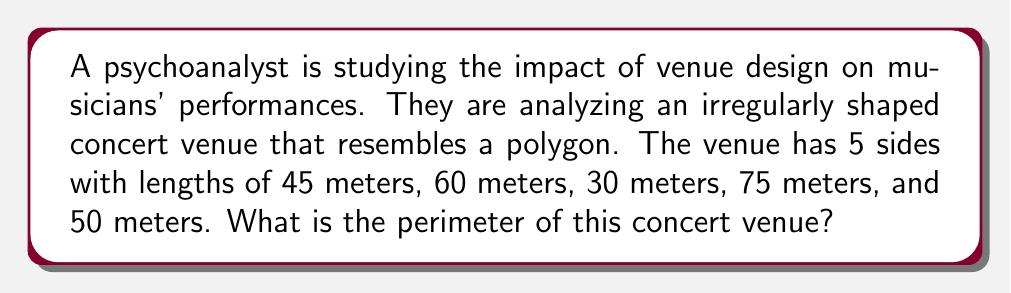Could you help me with this problem? To find the perimeter of the irregularly shaped concert venue, we need to sum up the lengths of all sides. Let's approach this step-by-step:

1. List the given side lengths:
   - Side 1: 45 meters
   - Side 2: 60 meters
   - Side 3: 30 meters
   - Side 4: 75 meters
   - Side 5: 50 meters

2. Set up the equation for the perimeter:
   $$P = s_1 + s_2 + s_3 + s_4 + s_5$$
   Where $P$ is the perimeter and $s_1, s_2, s_3, s_4, s_5$ are the side lengths.

3. Substitute the given values:
   $$P = 45 + 60 + 30 + 75 + 50$$

4. Perform the addition:
   $$P = 260$$

Therefore, the perimeter of the irregularly shaped concert venue is 260 meters.
Answer: 260 meters 